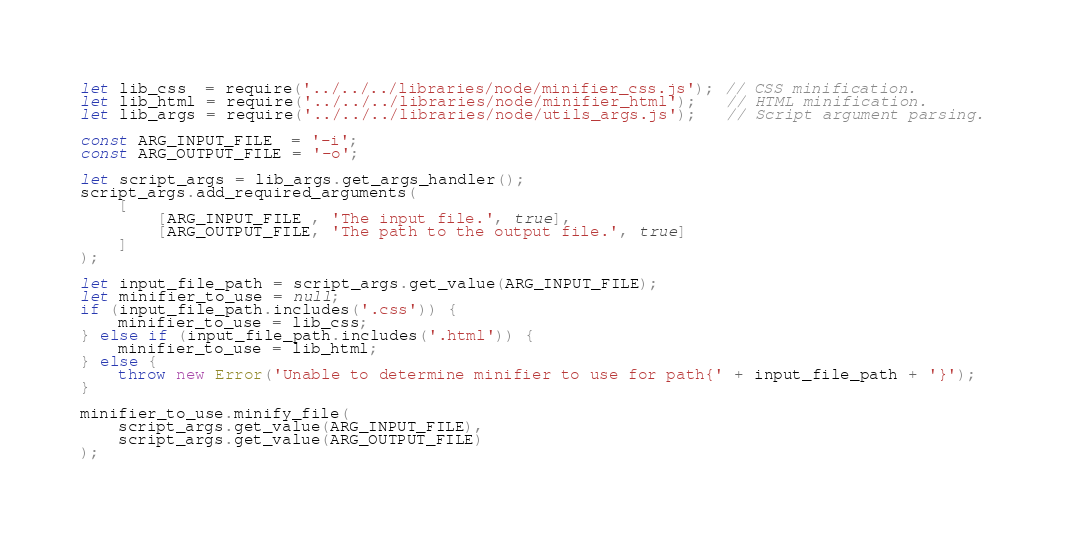<code> <loc_0><loc_0><loc_500><loc_500><_JavaScript_>let lib_css  = require('../../../libraries/node/minifier_css.js'); // CSS minification.
let lib_html = require('../../../libraries/node/minifier_html');   // HTML minification.
let lib_args = require('../../../libraries/node/utils_args.js');   // Script argument parsing.

const ARG_INPUT_FILE  = '-i';
const ARG_OUTPUT_FILE = '-o';

let script_args = lib_args.get_args_handler();
script_args.add_required_arguments(
    [
        [ARG_INPUT_FILE , 'The input file.', true],
        [ARG_OUTPUT_FILE, 'The path to the output file.', true]
    ]
);

let input_file_path = script_args.get_value(ARG_INPUT_FILE);
let minifier_to_use = null;
if (input_file_path.includes('.css')) {
    minifier_to_use = lib_css;
} else if (input_file_path.includes('.html')) {
    minifier_to_use = lib_html;
} else {
    throw new Error('Unable to determine minifier to use for path{' + input_file_path + '}');
}

minifier_to_use.minify_file(
    script_args.get_value(ARG_INPUT_FILE),
    script_args.get_value(ARG_OUTPUT_FILE)
);
</code> 